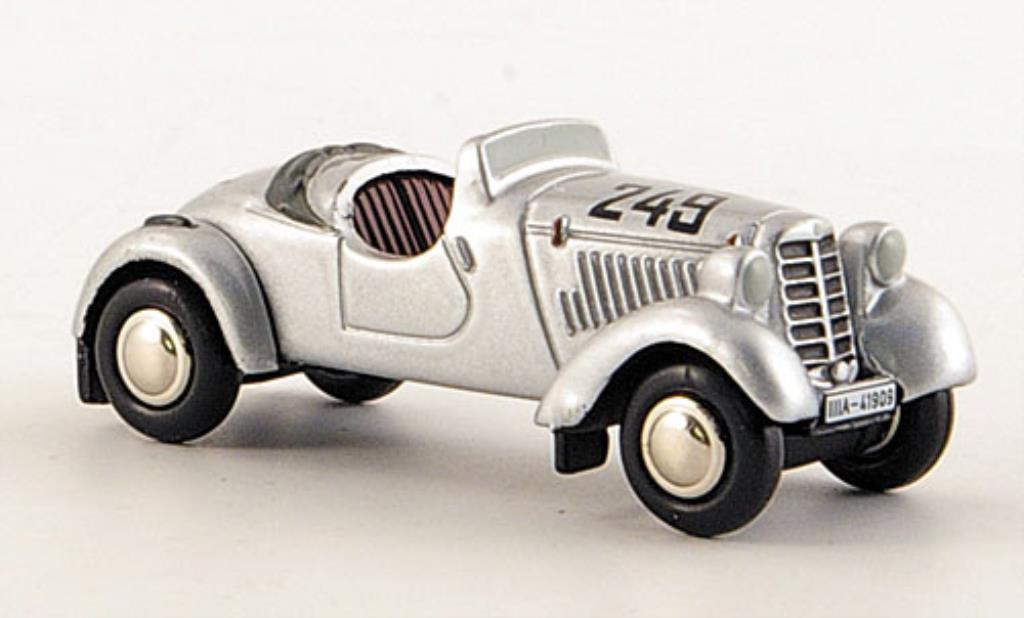Describe a realistic scene where this car is being showcased at a vintage car exhibition. The vintage car exhibition buzzed with excitement as enthusiasts from all walks of life gathered to witness automotive history. Under the warm lights, the silver race car with the number '243' gleamed proudly, capturing the essence of a bygone era. Displayed on a polished platform, it attracted a steady stream of admirers who marveled at its well-preserved condition. The exhibition placard detailed its storied past, referencing races in the 1930s and the endurance trials it conquered. A soft hum of conversations filled the room, mingling with the awe and reverence for this piece of racing legacy. Presenters highlighted its historical significance, drawing connections between its design and modern racing innovations. In the backdrop, nostalgic racing footage played, adding a dynamic touch to the display, evoking the thrill and glory of its heyday. 